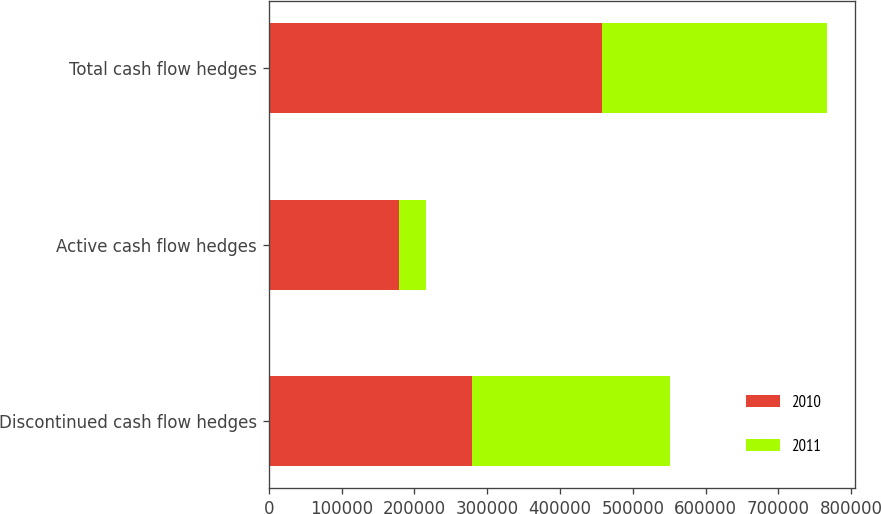Convert chart to OTSL. <chart><loc_0><loc_0><loc_500><loc_500><stacked_bar_chart><ecel><fcel>Discontinued cash flow hedges<fcel>Active cash flow hedges<fcel>Total cash flow hedges<nl><fcel>2010<fcel>279091<fcel>178862<fcel>457953<nl><fcel>2011<fcel>271595<fcel>36903<fcel>308498<nl></chart> 